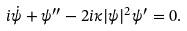Convert formula to latex. <formula><loc_0><loc_0><loc_500><loc_500>i \dot { \psi } + \psi ^ { \prime \prime } - 2 i \kappa | \psi | ^ { 2 } \psi ^ { \prime } = 0 .</formula> 